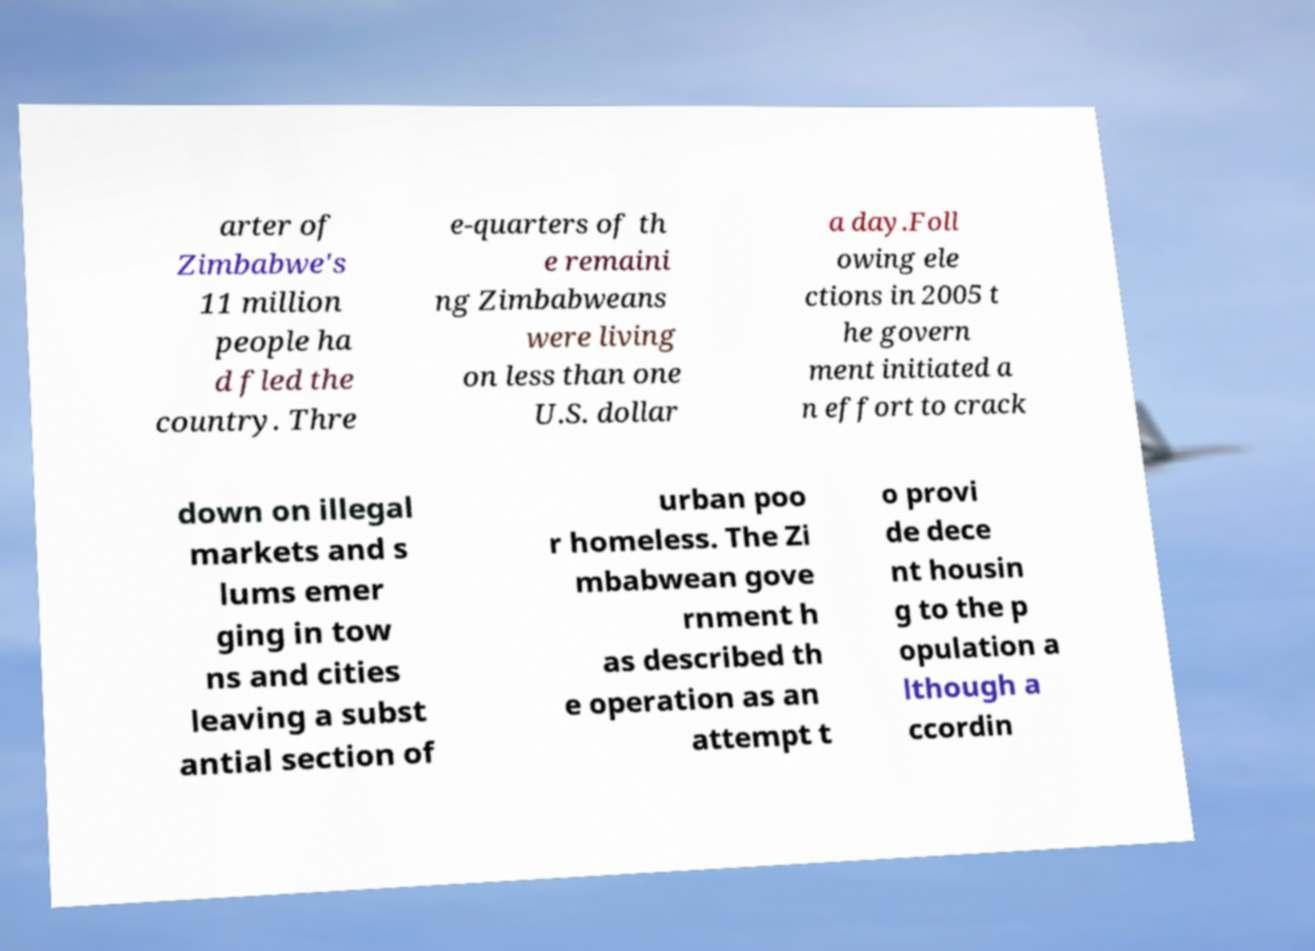I need the written content from this picture converted into text. Can you do that? arter of Zimbabwe's 11 million people ha d fled the country. Thre e-quarters of th e remaini ng Zimbabweans were living on less than one U.S. dollar a day.Foll owing ele ctions in 2005 t he govern ment initiated a n effort to crack down on illegal markets and s lums emer ging in tow ns and cities leaving a subst antial section of urban poo r homeless. The Zi mbabwean gove rnment h as described th e operation as an attempt t o provi de dece nt housin g to the p opulation a lthough a ccordin 